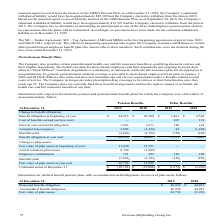According to Overseas Shipholding Group's financial document, What benefits are provided by the company to qualifying domestic retirees and their eligible dependents? certain postretirement health care and life insurance benefits. The document states: "etirement Benefit Plans The Company also provides certain postretirement health care and life insurance benefits to qualifying domestic retirees and t..." Also, can you calculate: What is the change in Interest cost on benefit obligation for pension benefits from December 31, 2018 and 2019? Based on the calculation: 1,802-1,673, the result is 129. This is based on the information: "Interest cost on benefit obligation 1,802 1,673 140 142 Interest cost on benefit obligation 1,802 1,673 140 142..." The key data points involved are: 1,673, 1,802. Also, can you calculate: What is the average Interest cost on benefit obligation for pension benefits for December 31, 2018 and 2019? To answer this question, I need to perform calculations using the financial data. The calculation is: (1,802+1,673) / 2, which equals 1737.5. This is based on the information: "Interest cost on benefit obligation 1,802 1,673 140 142 Interest cost on benefit obligation 1,802 1,673 140 142..." The key data points involved are: 1,673, 1,802. Additionally, In which year was Benefit obligation at beginning of year for pension benefits less than 45,000? According to the financial document, 2019. The relevant text states: "At December 31, 2019 2018 2019 2018..." Also, What was the Interest cost on benefit obligation in 2019 and 2018 respectively? The document shows two values: 1,802 and 1,673. From the document: "Interest cost on benefit obligation 1,802 1,673 140 142 Interest cost on benefit obligation 1,802 1,673 140 142..." Also, What was the Benefit obligation at year end of 2019 for pension benefits? According to the financial document, 46,936. The relevant text states: "Benefit obligation at year end 46,936 44,015 3,572 3,401..." 